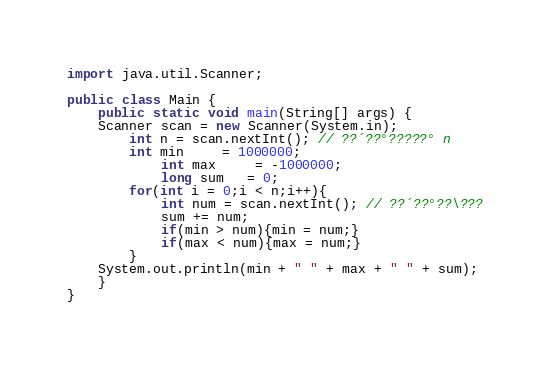Convert code to text. <code><loc_0><loc_0><loc_500><loc_500><_Java_>import java.util.Scanner;

public class Main {
    public static void main(String[] args) {
	Scanner scan = new Scanner(System.in);
		int n = scan.nextInt(); // ??´??°?????° n
		int min     = 1000000;
        	int max     = -1000000;
        	long sum   = 0;
		for(int i = 0;i < n;i++){
			int num = scan.nextInt(); // ??´??°??\???
			sum += num;
			if(min > num){min = num;}
			if(max < num){max = num;}
		}
	System.out.println(min + " " + max + " " + sum);
	}
}</code> 